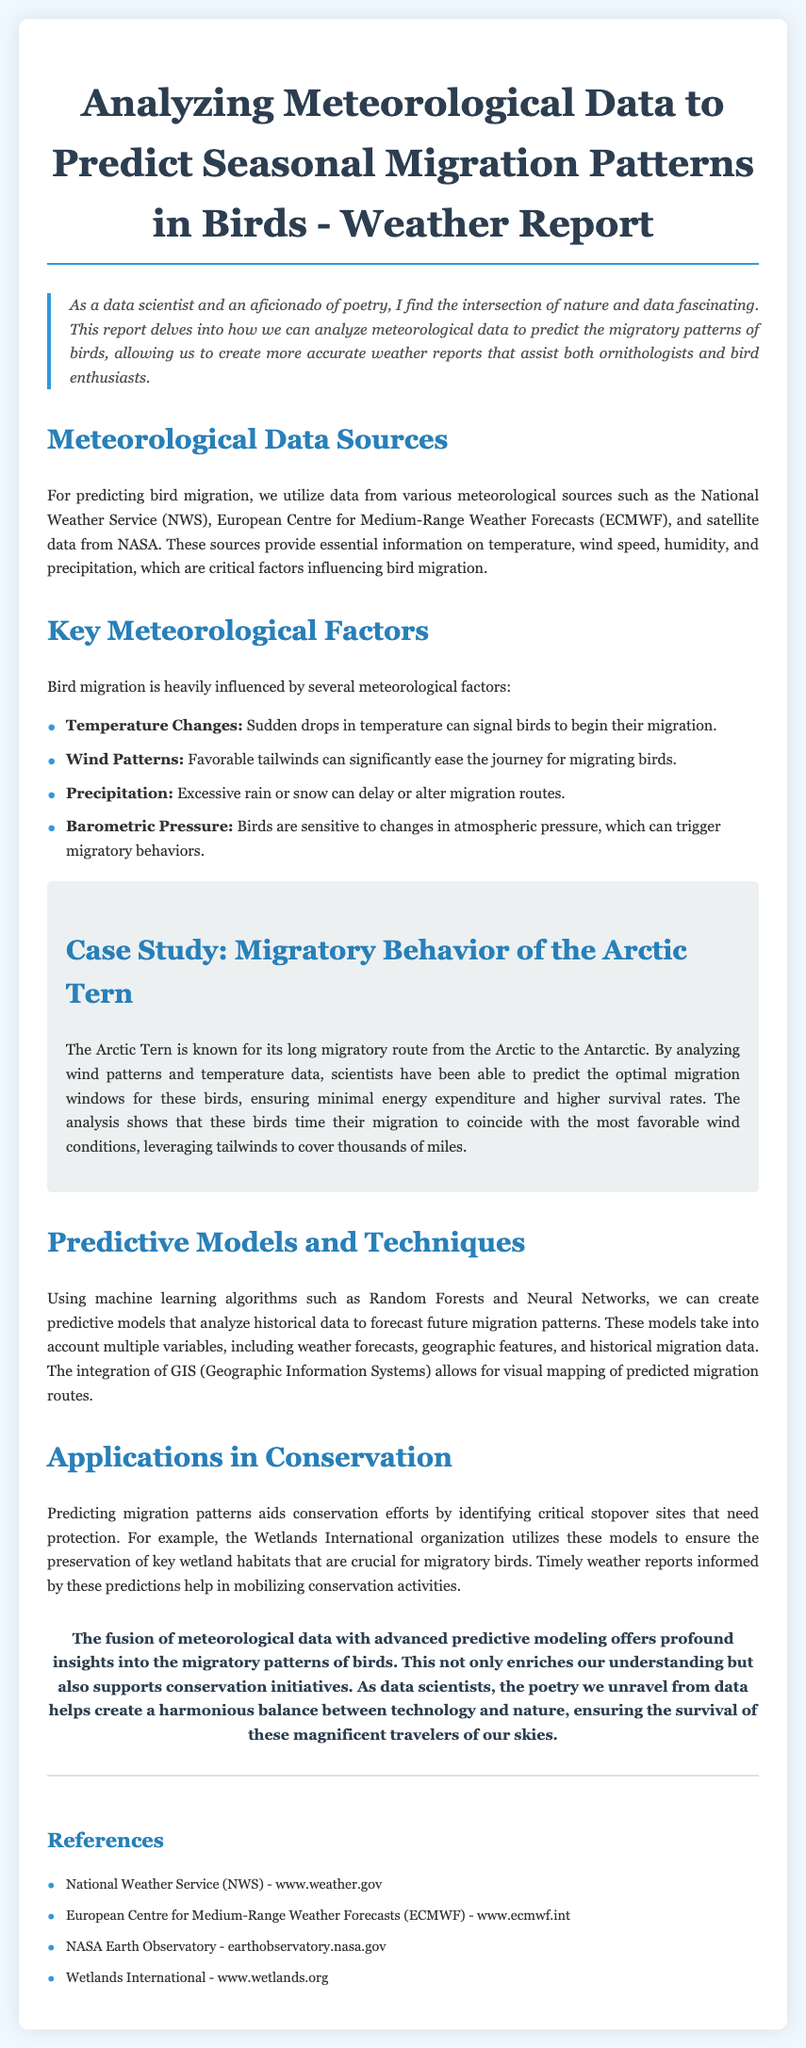What are the key meteorological factors influencing bird migration? The document lists key factors such as temperature changes, wind patterns, precipitation, and barometric pressure, which are critical for predicting bird migration patterns.
Answer: Temperature changes, wind patterns, precipitation, barometric pressure What machine learning algorithms are mentioned for predictive modeling? The report specifically mentions Random Forests and Neural Networks as the algorithms used for creating predictive models analyzing historical data.
Answer: Random Forests and Neural Networks What is the title of the case study featured in the report? The document outlines a case study that focuses on the migratory behavior of the Arctic Tern, highlighting its long migratory route.
Answer: Migratory Behavior of the Arctic Tern Which meteorological data sources are used in the analysis? The report names sources like the National Weather Service, European Centre for Medium-Range Weather Forecasts, and NASA satellite data as vital in the analysis of meteorological data.
Answer: National Weather Service, European Centre for Medium-Range Weather Forecasts, NASA What is the main conclusion drawn in this weather report? The conclusion emphasizes the significance of merging meteorological data with predictive modeling to deepen understanding and support conservation efforts.
Answer: Fusion of meteorological data with advanced predictive modeling Which organization utilizes predictive models for conservation efforts? The document states that Wetlands International employs these predictive models to help conserve critical wetland habitats important for migratory birds.
Answer: Wetlands International 